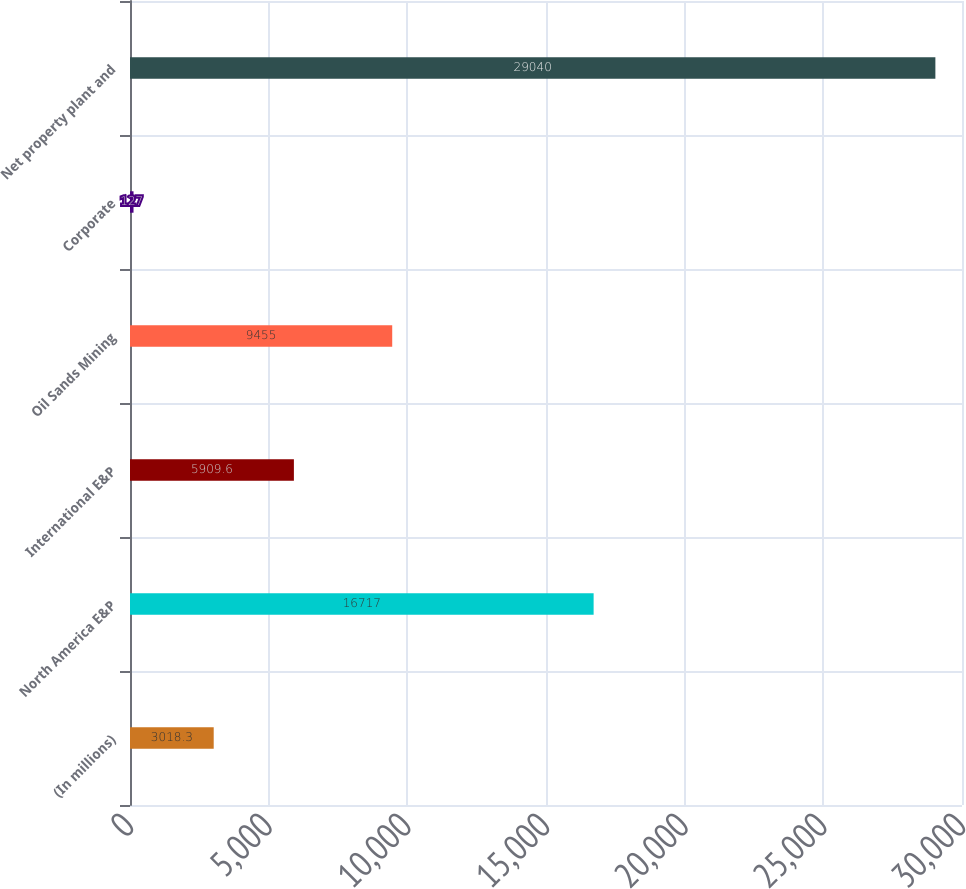Convert chart. <chart><loc_0><loc_0><loc_500><loc_500><bar_chart><fcel>(In millions)<fcel>North America E&P<fcel>International E&P<fcel>Oil Sands Mining<fcel>Corporate<fcel>Net property plant and<nl><fcel>3018.3<fcel>16717<fcel>5909.6<fcel>9455<fcel>127<fcel>29040<nl></chart> 